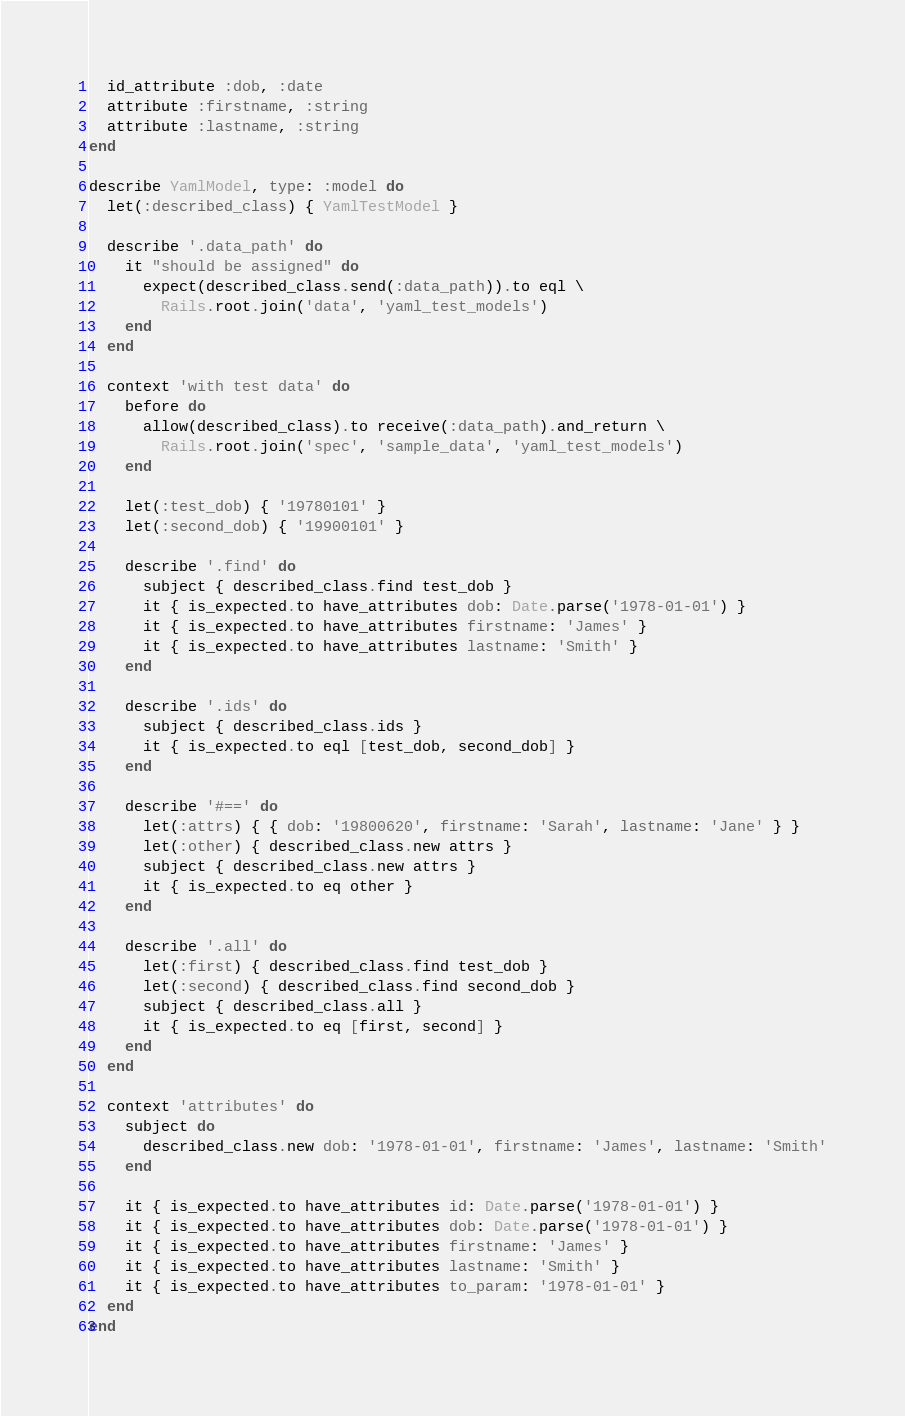Convert code to text. <code><loc_0><loc_0><loc_500><loc_500><_Ruby_>
  id_attribute :dob, :date
  attribute :firstname, :string
  attribute :lastname, :string
end

describe YamlModel, type: :model do
  let(:described_class) { YamlTestModel }

  describe '.data_path' do
    it "should be assigned" do
      expect(described_class.send(:data_path)).to eql \
        Rails.root.join('data', 'yaml_test_models')
    end
  end

  context 'with test data' do
    before do
      allow(described_class).to receive(:data_path).and_return \
        Rails.root.join('spec', 'sample_data', 'yaml_test_models')
    end

    let(:test_dob) { '19780101' }
    let(:second_dob) { '19900101' }

    describe '.find' do
      subject { described_class.find test_dob }
      it { is_expected.to have_attributes dob: Date.parse('1978-01-01') }
      it { is_expected.to have_attributes firstname: 'James' }
      it { is_expected.to have_attributes lastname: 'Smith' }
    end

    describe '.ids' do
      subject { described_class.ids }
      it { is_expected.to eql [test_dob, second_dob] }
    end

    describe '#==' do
      let(:attrs) { { dob: '19800620', firstname: 'Sarah', lastname: 'Jane' } }
      let(:other) { described_class.new attrs }
      subject { described_class.new attrs }
      it { is_expected.to eq other }
    end

    describe '.all' do
      let(:first) { described_class.find test_dob }
      let(:second) { described_class.find second_dob }
      subject { described_class.all }
      it { is_expected.to eq [first, second] }
    end
  end

  context 'attributes' do
    subject do
      described_class.new dob: '1978-01-01', firstname: 'James', lastname: 'Smith'
    end

    it { is_expected.to have_attributes id: Date.parse('1978-01-01') }
    it { is_expected.to have_attributes dob: Date.parse('1978-01-01') }
    it { is_expected.to have_attributes firstname: 'James' }
    it { is_expected.to have_attributes lastname: 'Smith' }
    it { is_expected.to have_attributes to_param: '1978-01-01' }
  end
end
</code> 